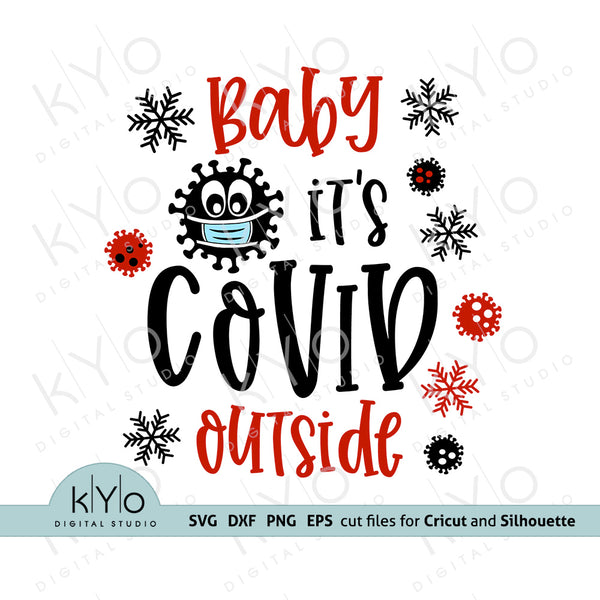Considering the details of the graphic design, what is the likely purpose of this image, and what cultural or societal context does it reference? The image, featuring a whimsical depiction of a virus particle wearing a mask surrounded by snowflakes and bold lettering stating 'Baby it's COVID outside', is designed as a digital cut file for personal crafting machines such as Cricut and Silhouette. This design is typically used for creating items like t-shirts, mugs, and holiday decorations, capitalizing on DIY crafting trends. The phrase is a playful twist on the classic holiday song 'Baby, It's Cold Outside', which has been adapted to reflect the ongoing COVID-19 pandemic. This representation not only serves a decorative purpose but also acts as a commentary on how the pandemic has altered traditional festive celebrations, inserting a note of current events into holiday humor. It reflects a blending of holiday spirit with the omnipresent influence of the pandemic, poking fun at the situation in a manner that could both amuse and provoke thought about our collective experience during these unprecedented times. 